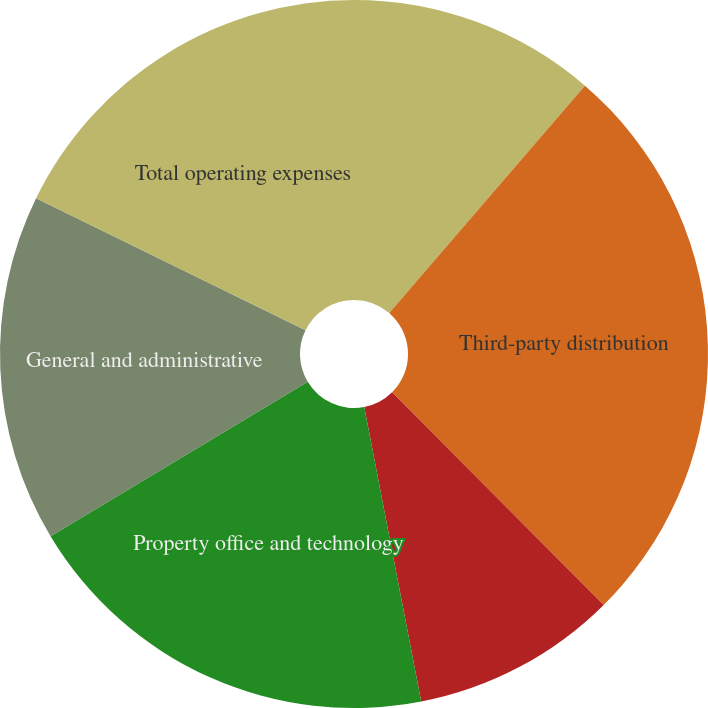Convert chart. <chart><loc_0><loc_0><loc_500><loc_500><pie_chart><fcel>Employee compensation<fcel>Third-party distribution<fcel>Marketing<fcel>Property office and technology<fcel>General and administrative<fcel>Total operating expenses<nl><fcel>11.31%<fcel>26.23%<fcel>9.42%<fcel>19.43%<fcel>15.86%<fcel>17.75%<nl></chart> 